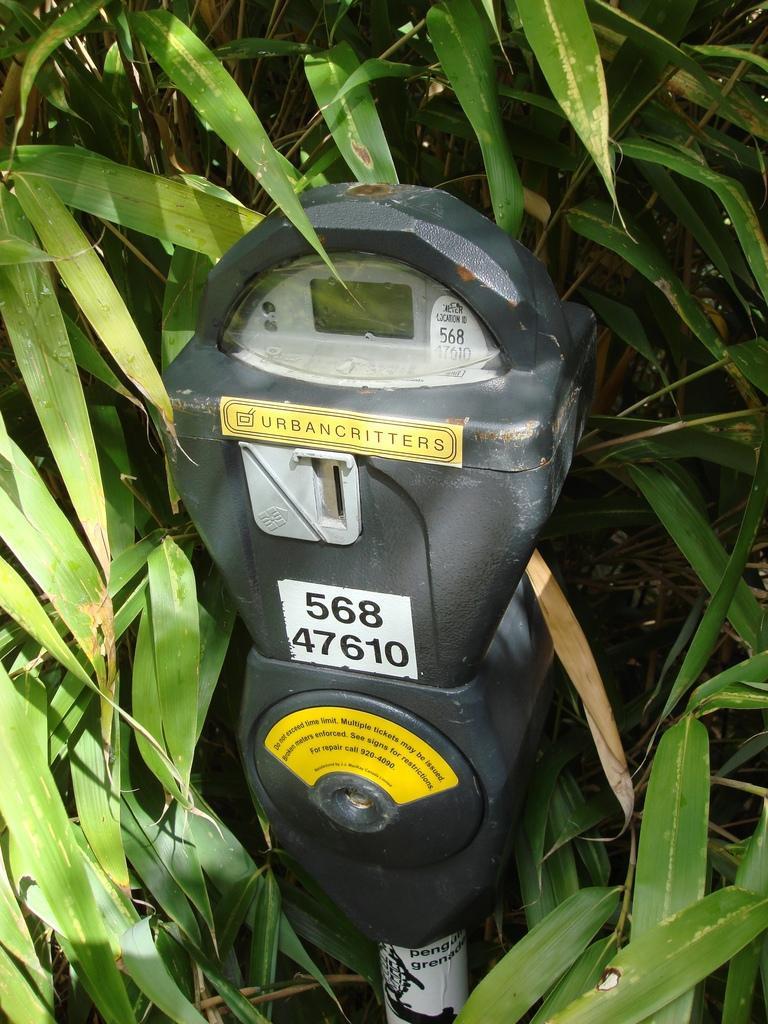<image>
Offer a succinct explanation of the picture presented. Parking meter with a yellow sticker that says Urbancritters. 